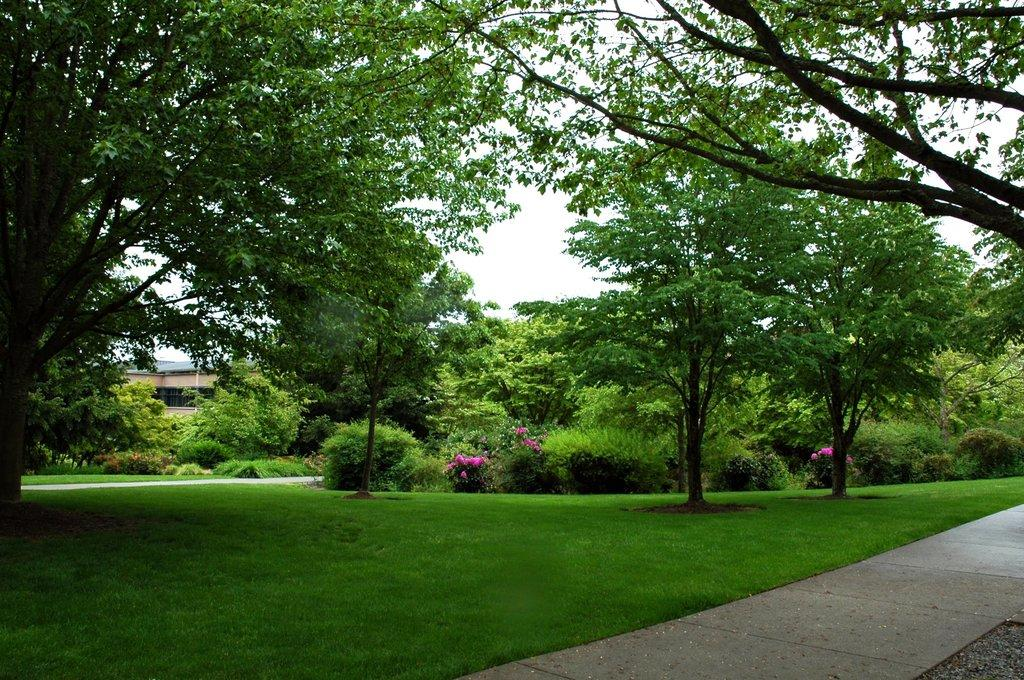What type of vegetation can be seen in the image? There is grass, plants, flowers, and trees in the image. What type of structure is present in the image? There is a house in the image. What is visible in the background of the image? The sky is visible in the background of the image. What type of leather material can be seen on the toad in the image? There is no toad or leather material present in the image. What direction is the front of the house facing in the image? The facts provided do not specify the direction the house is facing in the image. 